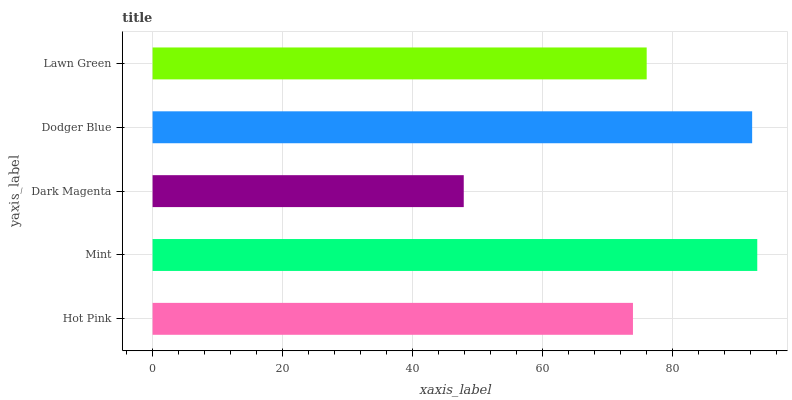Is Dark Magenta the minimum?
Answer yes or no. Yes. Is Mint the maximum?
Answer yes or no. Yes. Is Mint the minimum?
Answer yes or no. No. Is Dark Magenta the maximum?
Answer yes or no. No. Is Mint greater than Dark Magenta?
Answer yes or no. Yes. Is Dark Magenta less than Mint?
Answer yes or no. Yes. Is Dark Magenta greater than Mint?
Answer yes or no. No. Is Mint less than Dark Magenta?
Answer yes or no. No. Is Lawn Green the high median?
Answer yes or no. Yes. Is Lawn Green the low median?
Answer yes or no. Yes. Is Hot Pink the high median?
Answer yes or no. No. Is Dodger Blue the low median?
Answer yes or no. No. 